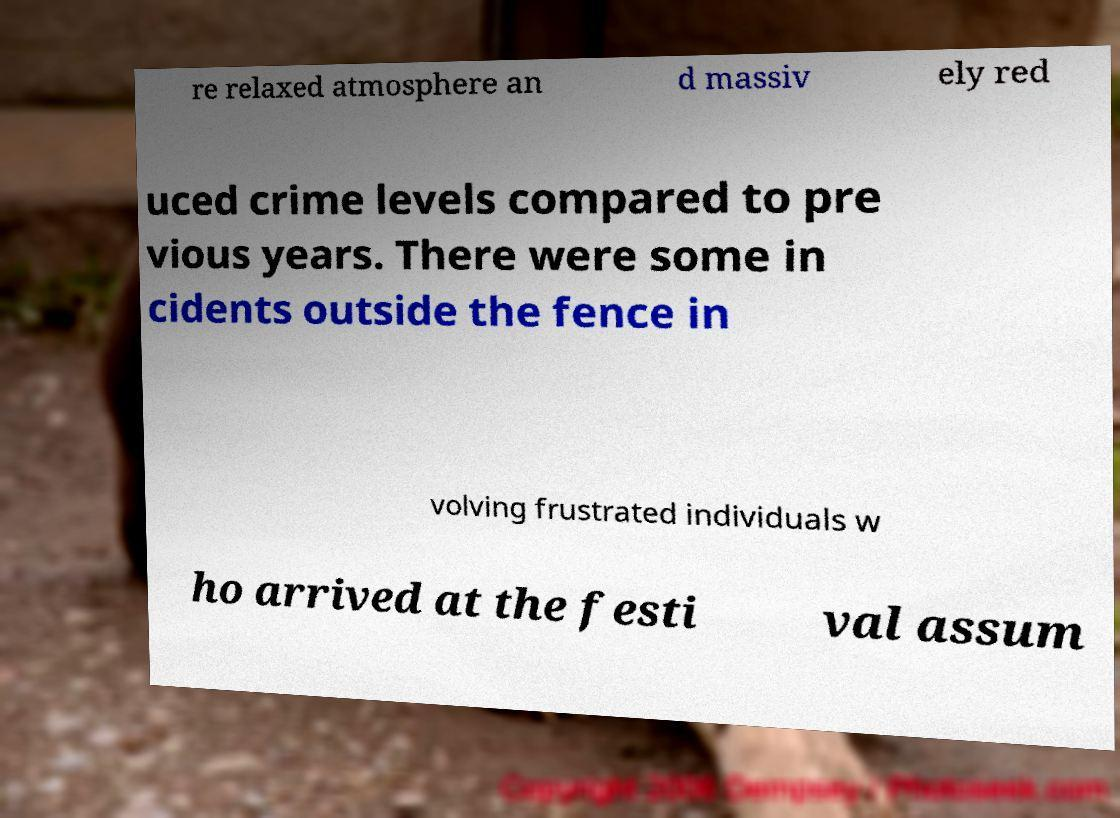Please identify and transcribe the text found in this image. re relaxed atmosphere an d massiv ely red uced crime levels compared to pre vious years. There were some in cidents outside the fence in volving frustrated individuals w ho arrived at the festi val assum 